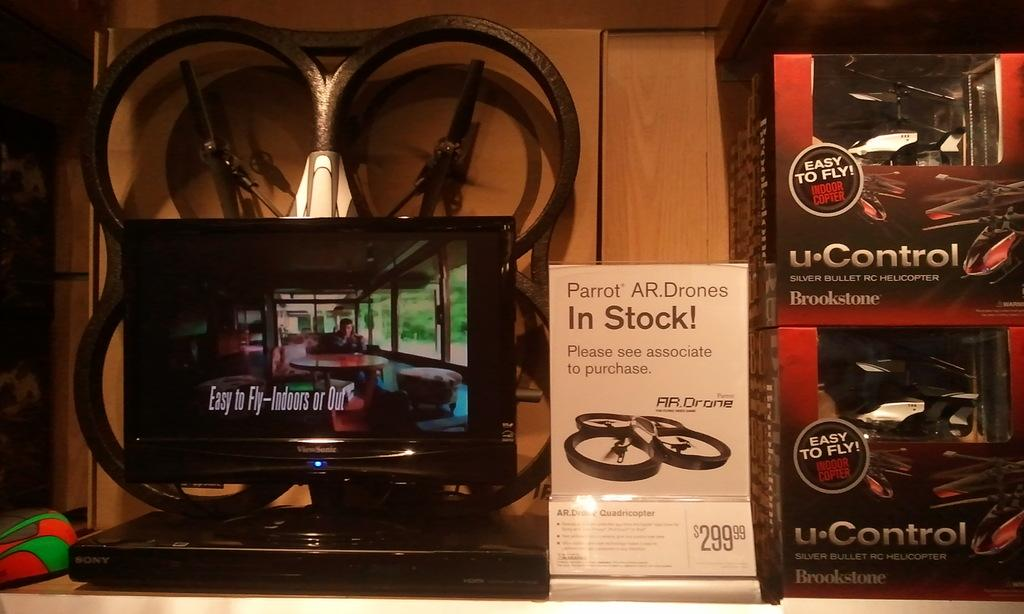<image>
Describe the image concisely. a white in stock sign next to a u control item 